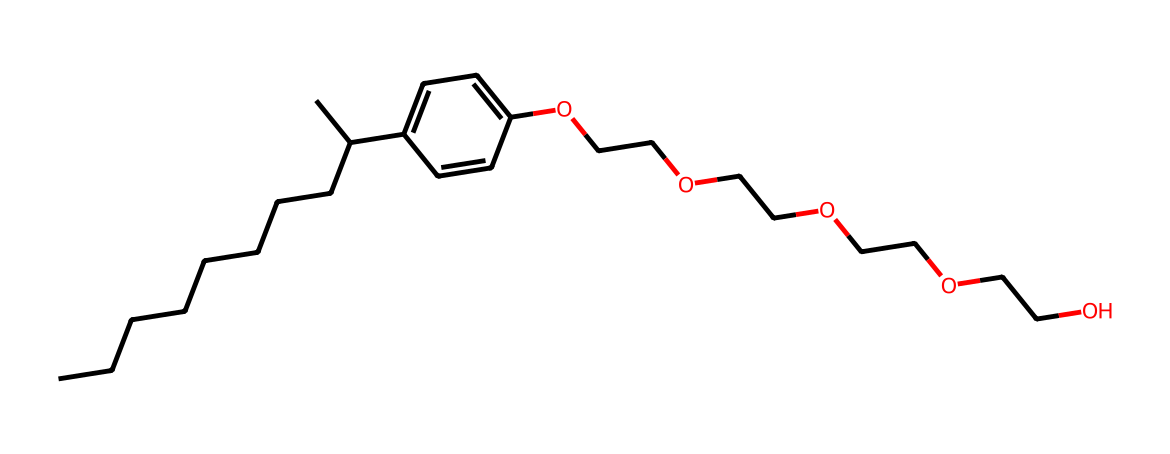What is the name of this chemical? The provided SMILES representation corresponds to nonylphenol ethoxylate, where the core structure includes a nonyl group linked to a phenolic ring and ethylene oxide units.
Answer: nonylphenol ethoxylate How many carbon atoms are in this chemical? By analyzing the SMILES, we count the carbon atoms in the hydrocarbon chain and the rings. The nonyl group (C9), the phenyl group (C6), and additional carbons from the ethylene oxide chains together total 20 carbon atoms.
Answer: 20 What type of chemical functional group is present in this molecule? The phenolic -OH group indicates the presence of an alcohol since it has a hydroxyl group (-OH) attached to an aromatic carbon.
Answer: alcohol What is the primary use of nonylphenol ethoxylate? Nonylphenol ethoxylate is commonly used as a surfactant in cleaning products due to its ability to reduce surface tension and emulsify oils and fats.
Answer: surfactant How many ethylene oxide units are present in this chemical? By examining the SMILES structure, we identify four ethylene glycol units (OCC) linked by ether bonds to the nonylphenol moiety, suggesting there are four ethylene oxide units in the molecule.
Answer: 4 What property does this chemical impart to cleaning products? Nonylphenol ethoxylate enhances the wetting and solubilization properties of the cleansers, improving their ability to disperse and remove dirt and grease.
Answer: wetting agent Is this chemical biodegradable? Nonylphenol ethoxylate is known to degrade slowly and its degradation products can be harmful to aquatic environments, raising environmental concerns regarding its use.
Answer: no 